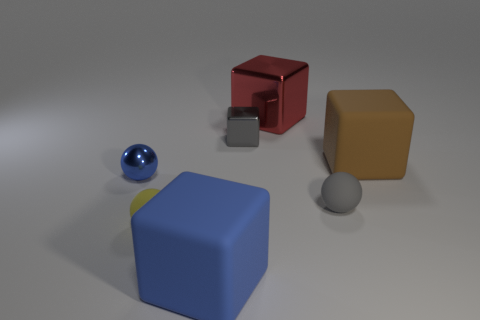What material is the tiny gray object that is the same shape as the blue shiny thing?
Your response must be concise. Rubber. There is a tiny gray thing that is right of the tiny gray thing behind the small blue thing; what is its material?
Your answer should be compact. Rubber. Do the large red metallic thing and the big matte object in front of the brown thing have the same shape?
Your answer should be very brief. Yes. What number of matte things are either small blocks or small purple cylinders?
Offer a terse response. 0. What is the color of the matte block behind the cube on the left side of the gray object behind the blue metal object?
Give a very brief answer. Brown. What number of other objects are the same material as the tiny yellow object?
Provide a succinct answer. 3. Does the blue object on the left side of the large blue matte cube have the same shape as the yellow matte object?
Ensure brevity in your answer.  Yes. What number of large things are yellow shiny objects or yellow objects?
Offer a terse response. 0. Is the number of blue metal things right of the big brown block the same as the number of small shiny objects that are in front of the yellow thing?
Your answer should be very brief. Yes. What number of other things are the same color as the large shiny cube?
Provide a short and direct response. 0. 